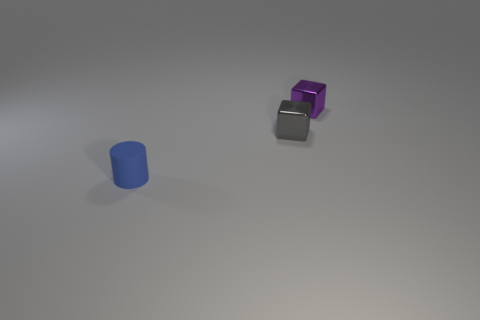What number of gray metallic things are behind the small metal cube that is on the right side of the gray metal thing?
Offer a terse response. 0. Are there any tiny red shiny things of the same shape as the gray shiny object?
Provide a succinct answer. No. There is a tiny metal object that is in front of the purple metallic block; does it have the same shape as the thing in front of the gray metallic block?
Give a very brief answer. No. The object that is both to the left of the purple object and behind the blue rubber cylinder has what shape?
Offer a terse response. Cube. Is there a green shiny cylinder of the same size as the gray metallic cube?
Ensure brevity in your answer.  No. There is a small matte cylinder; is its color the same as the tiny metal block left of the purple thing?
Give a very brief answer. No. What material is the purple cube?
Keep it short and to the point. Metal. The tiny shiny object right of the tiny gray shiny thing is what color?
Your answer should be very brief. Purple. What number of tiny metallic objects have the same color as the tiny rubber cylinder?
Your response must be concise. 0. What number of things are on the left side of the gray shiny thing and behind the tiny blue rubber object?
Your answer should be compact. 0. 